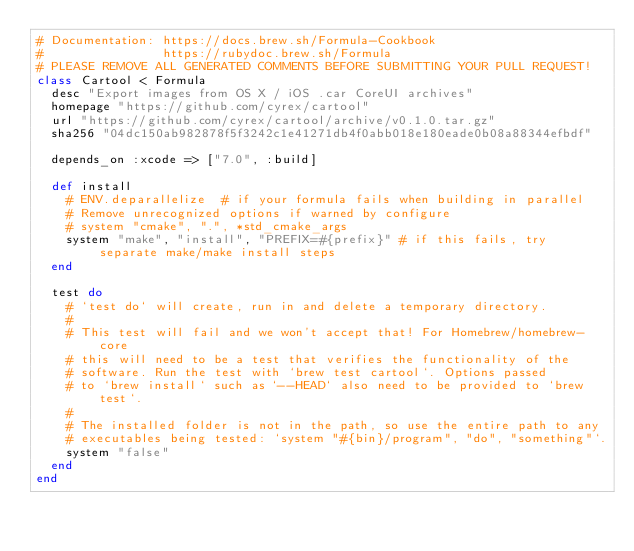<code> <loc_0><loc_0><loc_500><loc_500><_Ruby_># Documentation: https://docs.brew.sh/Formula-Cookbook
#                https://rubydoc.brew.sh/Formula
# PLEASE REMOVE ALL GENERATED COMMENTS BEFORE SUBMITTING YOUR PULL REQUEST!
class Cartool < Formula
  desc "Export images from OS X / iOS .car CoreUI archives"
  homepage "https://github.com/cyrex/cartool"
  url "https://github.com/cyrex/cartool/archive/v0.1.0.tar.gz"
  sha256 "04dc150ab982878f5f3242c1e41271db4f0abb018e180eade0b08a88344efbdf"

  depends_on :xcode => ["7.0", :build]

  def install
    # ENV.deparallelize  # if your formula fails when building in parallel
    # Remove unrecognized options if warned by configure
    # system "cmake", ".", *std_cmake_args
    system "make", "install", "PREFIX=#{prefix}" # if this fails, try separate make/make install steps
  end

  test do
    # `test do` will create, run in and delete a temporary directory.
    #
    # This test will fail and we won't accept that! For Homebrew/homebrew-core
    # this will need to be a test that verifies the functionality of the
    # software. Run the test with `brew test cartool`. Options passed
    # to `brew install` such as `--HEAD` also need to be provided to `brew test`.
    #
    # The installed folder is not in the path, so use the entire path to any
    # executables being tested: `system "#{bin}/program", "do", "something"`.
    system "false"
  end
end
</code> 